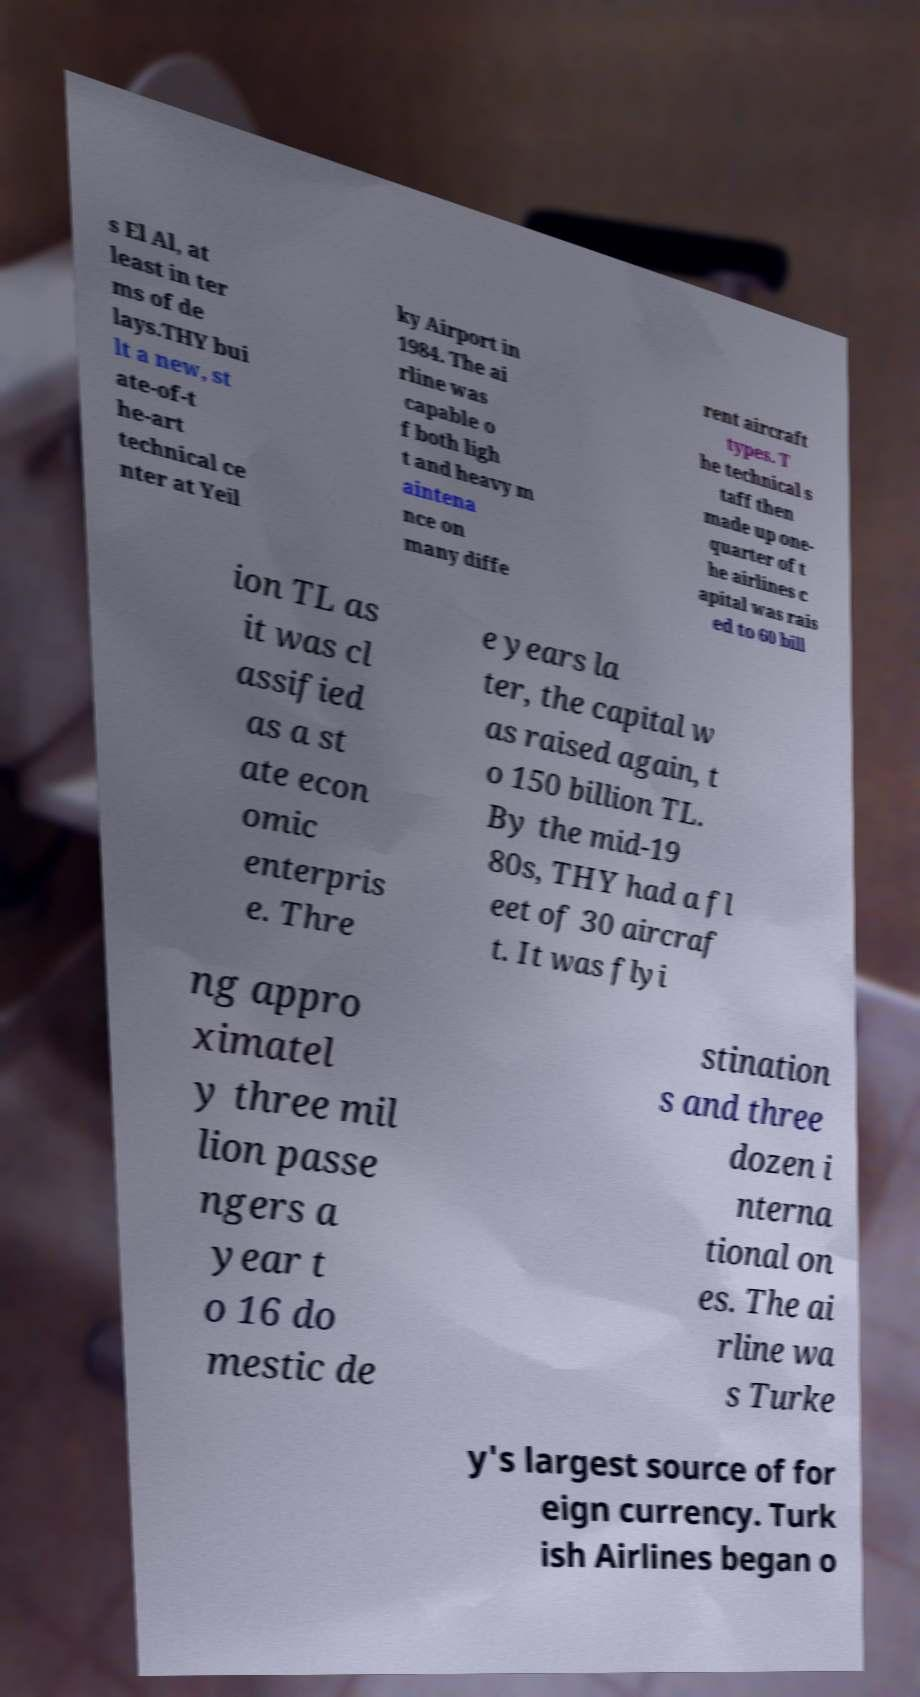There's text embedded in this image that I need extracted. Can you transcribe it verbatim? s El Al, at least in ter ms of de lays.THY bui lt a new, st ate-of-t he-art technical ce nter at Yeil ky Airport in 1984. The ai rline was capable o f both ligh t and heavy m aintena nce on many diffe rent aircraft types. T he technical s taff then made up one- quarter of t he airlines c apital was rais ed to 60 bill ion TL as it was cl assified as a st ate econ omic enterpris e. Thre e years la ter, the capital w as raised again, t o 150 billion TL. By the mid-19 80s, THY had a fl eet of 30 aircraf t. It was flyi ng appro ximatel y three mil lion passe ngers a year t o 16 do mestic de stination s and three dozen i nterna tional on es. The ai rline wa s Turke y's largest source of for eign currency. Turk ish Airlines began o 